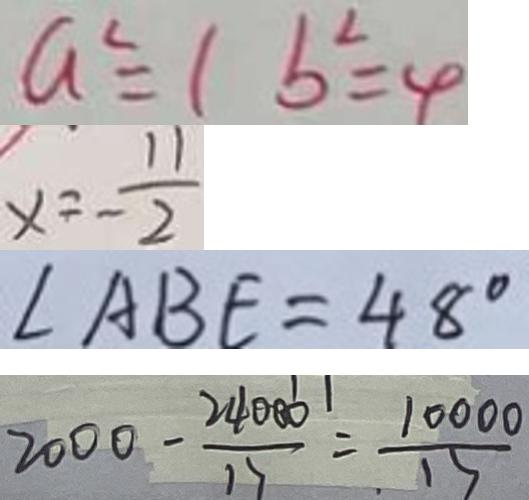<formula> <loc_0><loc_0><loc_500><loc_500>a ^ { 2 } = 1 b ^ { 2 } = 4 
 x = - \frac { 1 1 } { 2 } 
 \angle A B E = 4 8 ^ { \circ } 
 2 0 0 0 - \frac { 2 4 0 0 0 } { 1 7 } = \frac { 1 0 0 0 0 } { 1 5 }</formula> 